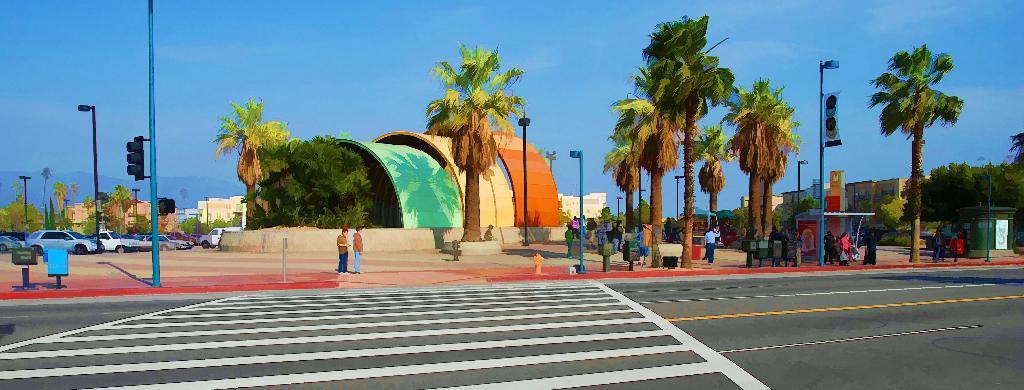Could you give a brief overview of what you see in this image? This is the picture of a city. In this image there are buildings and trees and there is a mountain and there are street lights on the footpath and there are group of people on the footpath and there are vehicles. In the foreground there is a fire hydrant and there are poles on the footpath. At the top there is sky. At the bottom there is a road. 